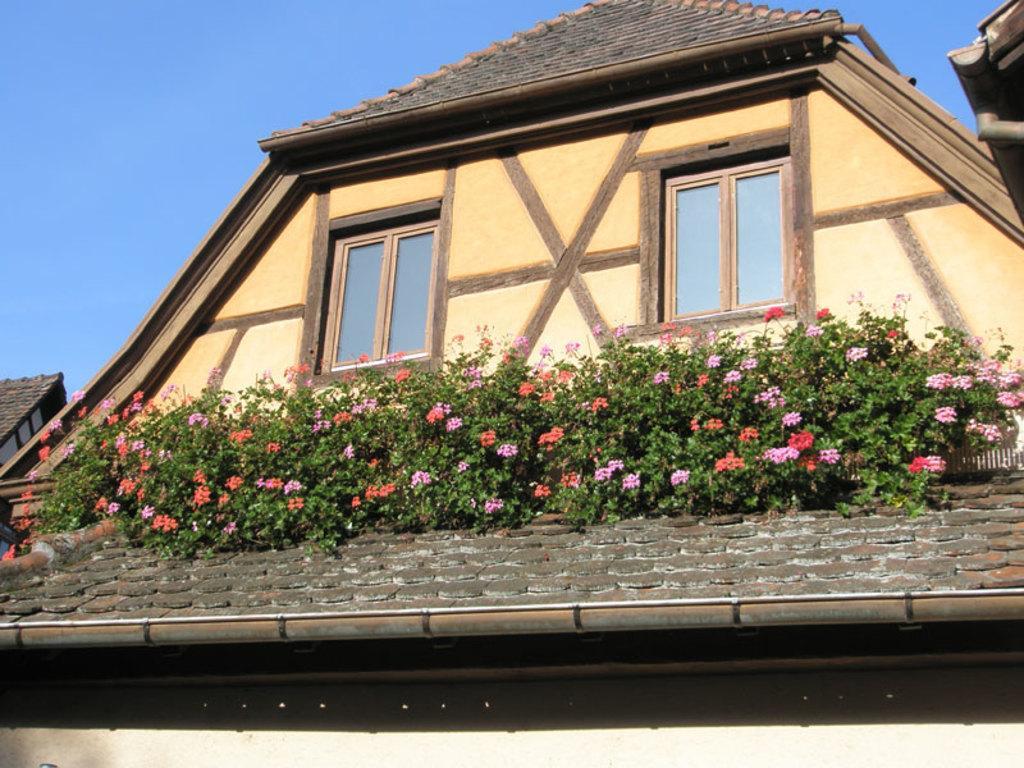How would you summarize this image in a sentence or two? In this image we can see there is a building and on the roof there are flowers and plans. In the background there is the sky. 